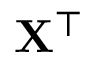<formula> <loc_0><loc_0><loc_500><loc_500>{ X ^ { \top } }</formula> 